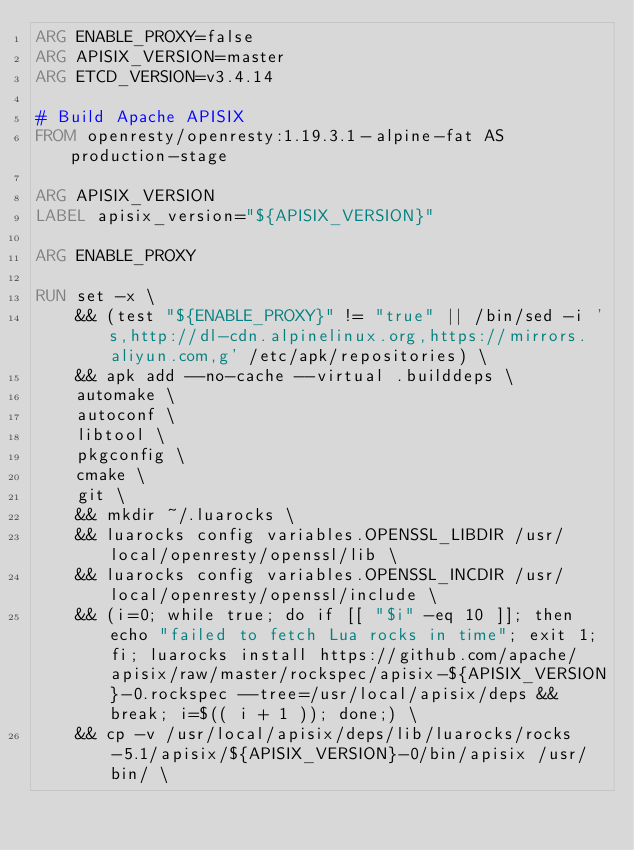Convert code to text. <code><loc_0><loc_0><loc_500><loc_500><_Dockerfile_>ARG ENABLE_PROXY=false
ARG APISIX_VERSION=master
ARG ETCD_VERSION=v3.4.14

# Build Apache APISIX
FROM openresty/openresty:1.19.3.1-alpine-fat AS production-stage

ARG APISIX_VERSION
LABEL apisix_version="${APISIX_VERSION}"

ARG ENABLE_PROXY

RUN set -x \
    && (test "${ENABLE_PROXY}" != "true" || /bin/sed -i 's,http://dl-cdn.alpinelinux.org,https://mirrors.aliyun.com,g' /etc/apk/repositories) \
    && apk add --no-cache --virtual .builddeps \
    automake \
    autoconf \
    libtool \
    pkgconfig \
    cmake \
    git \
    && mkdir ~/.luarocks \
    && luarocks config variables.OPENSSL_LIBDIR /usr/local/openresty/openssl/lib \
    && luarocks config variables.OPENSSL_INCDIR /usr/local/openresty/openssl/include \
    && (i=0; while true; do if [[ "$i" -eq 10 ]]; then echo "failed to fetch Lua rocks in time"; exit 1; fi; luarocks install https://github.com/apache/apisix/raw/master/rockspec/apisix-${APISIX_VERSION}-0.rockspec --tree=/usr/local/apisix/deps && break; i=$(( i + 1 )); done;) \
    && cp -v /usr/local/apisix/deps/lib/luarocks/rocks-5.1/apisix/${APISIX_VERSION}-0/bin/apisix /usr/bin/ \</code> 